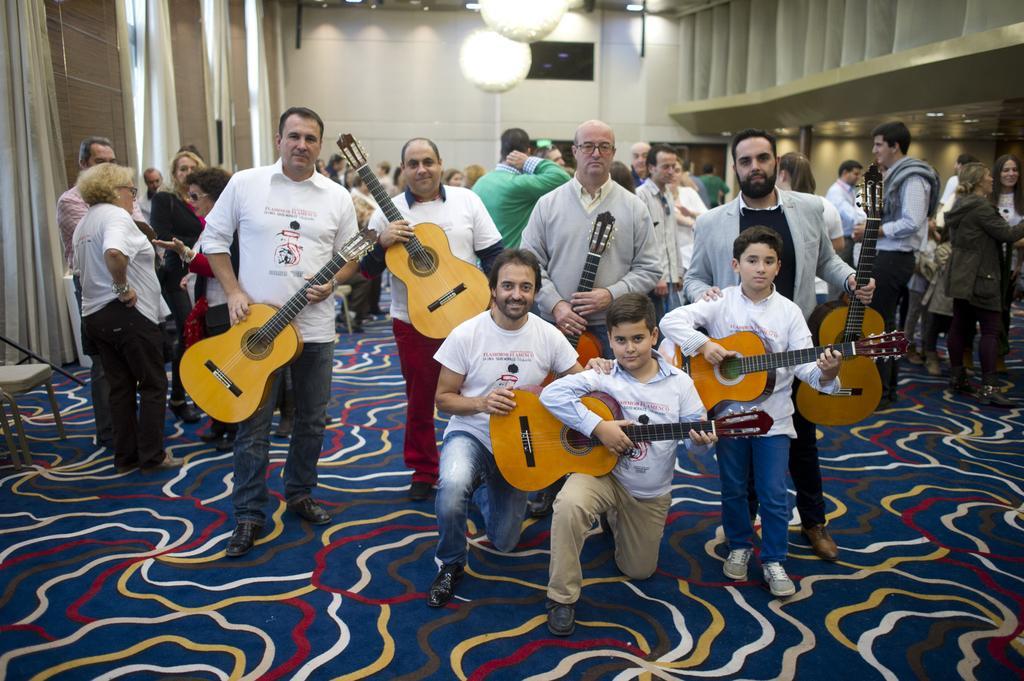Can you describe this image briefly? This image is taken in a room. In this image there is a floor mat all over the room. In the left side of the image there is a chair and a curtain to a wall. In the right side of the image there are few people standing and there is a wall with lights. In this room there are many people. In the middle of the image few people are holding guitar. 